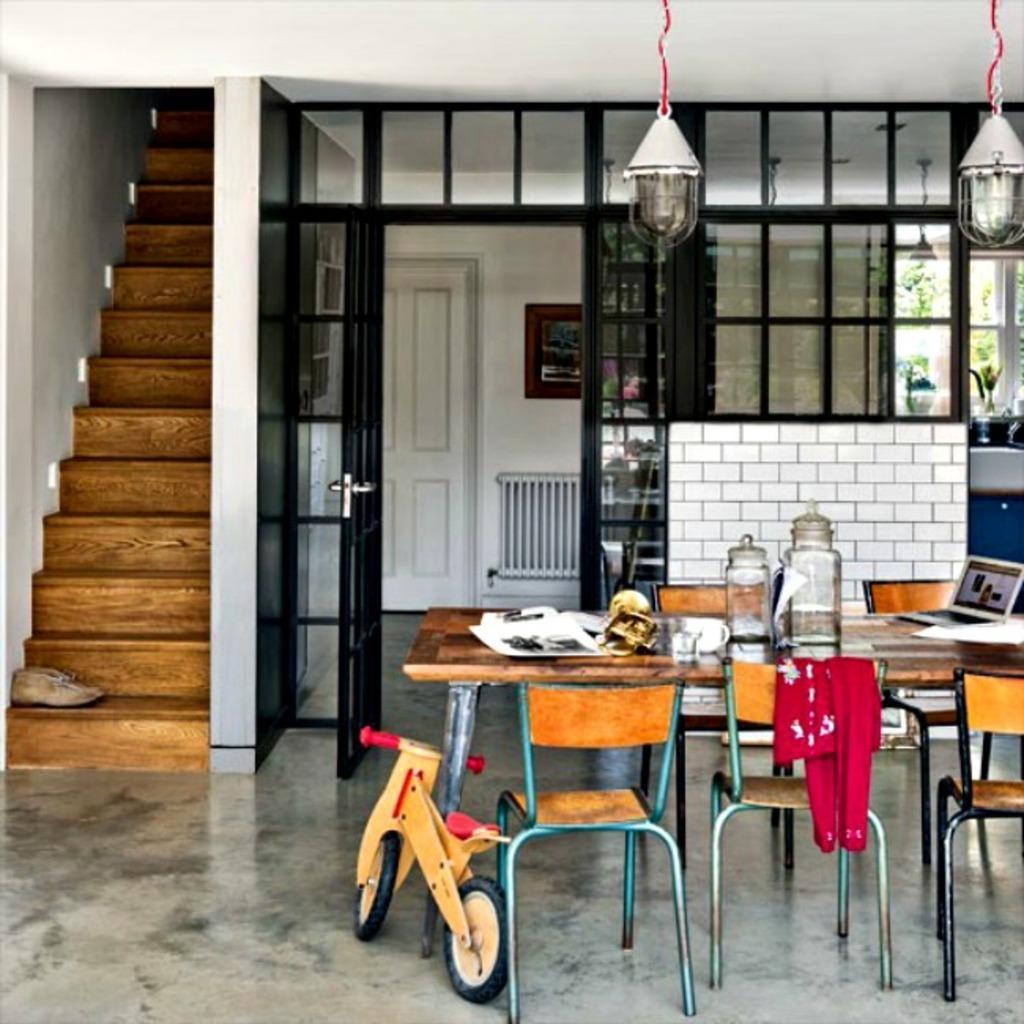Please provide a concise description of this image. In this picture there is a glass, laptop, paper , cup on the table. Red cloth is on the chair. There is a cycle. There are shoe on the staircase. To the left, there is a door, bulbs changed to a wire. To the right, there is a vase and a tree in the background. 